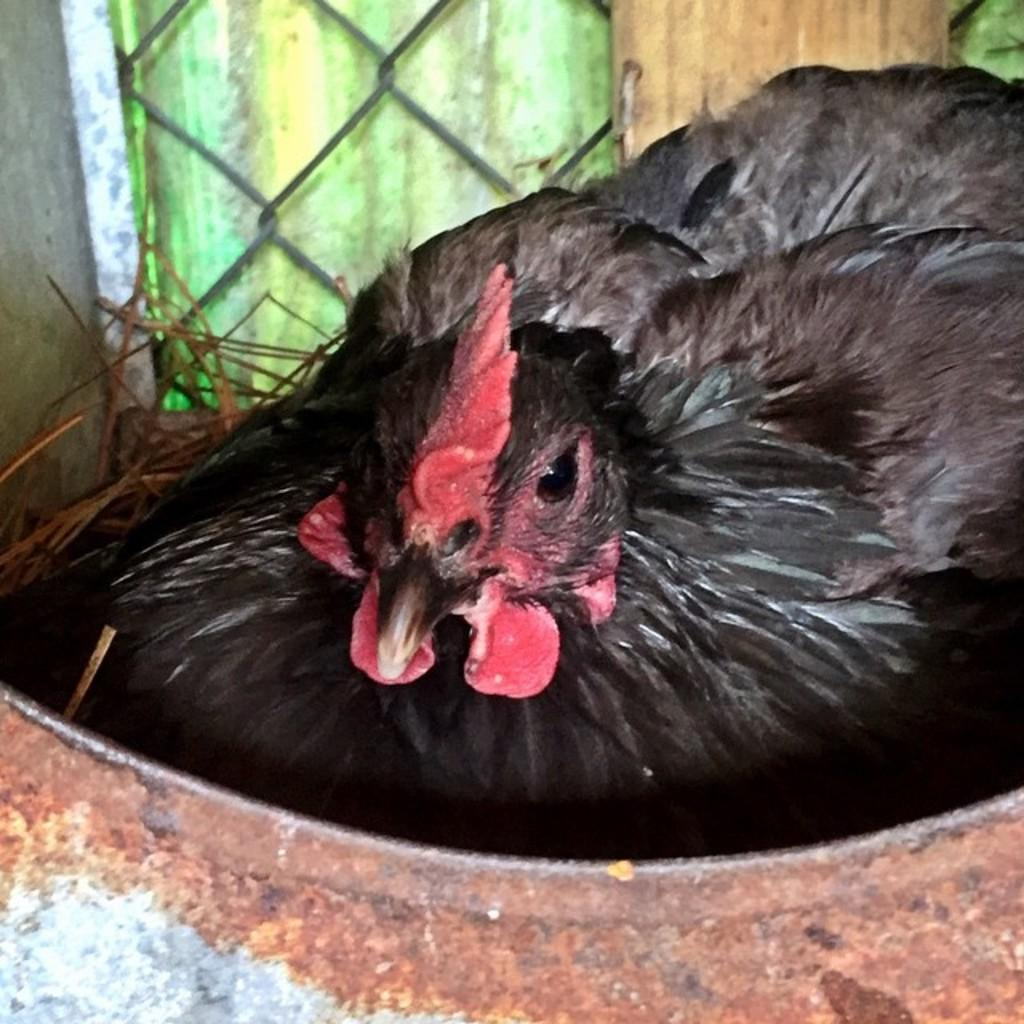What is the main subject of the image? There is a hen in the center of the image. Where is the hen located in the image? The hen is sitting in a container. What can be seen in the background of the image? There is dry grass, a mesh, and a wall in the background of the image. How many pies are being served on the wrist in the image? There are no pies or wrists present in the image. What type of sheet is covering the hen in the image? There is no sheet covering the hen in the image; it is sitting in a container. 